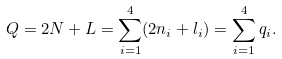<formula> <loc_0><loc_0><loc_500><loc_500>Q = 2 N + L = \sum _ { i = 1 } ^ { 4 } ( 2 n _ { i } + l _ { i } ) = \sum _ { i = 1 } ^ { 4 } q _ { i } .</formula> 